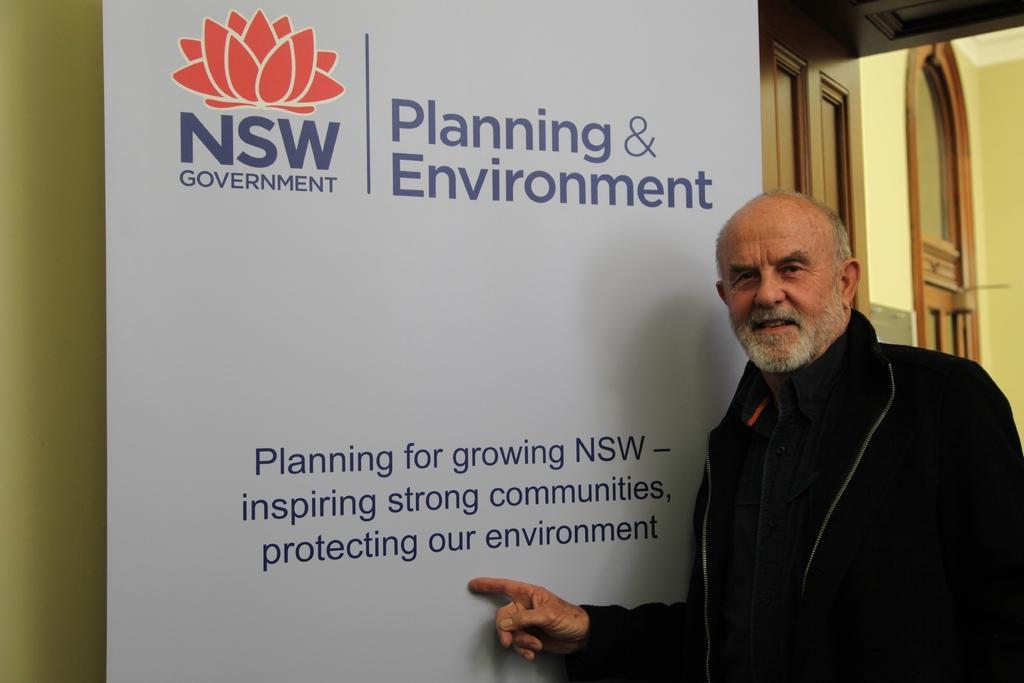Describe this image in one or two sentences. This person wore black jacket and pointing towards this white hoarding. 